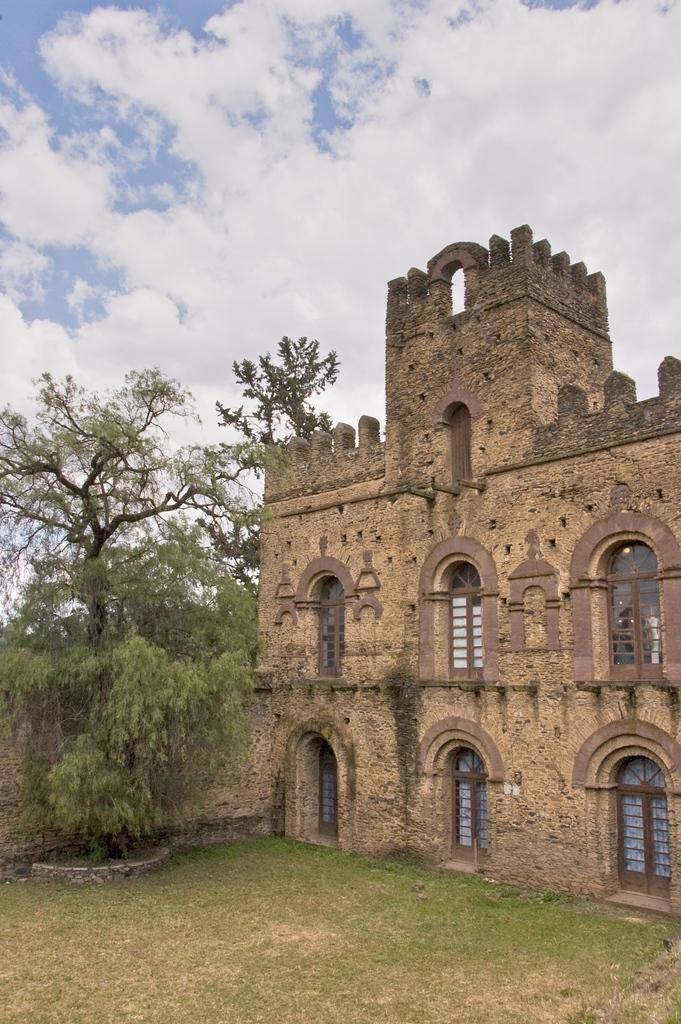What type of structure is in the image? There is a fort in the image. What type of vegetation can be seen in the image? There are trees in the image. What is visible in the sky at the top of the image? Clouds are visible in the sky at the top of the image. What is visible at the bottom of the image? The ground is visible at the bottom of the image. What title does the boat have in the image? There is no boat present in the image, so it does not have a title. 